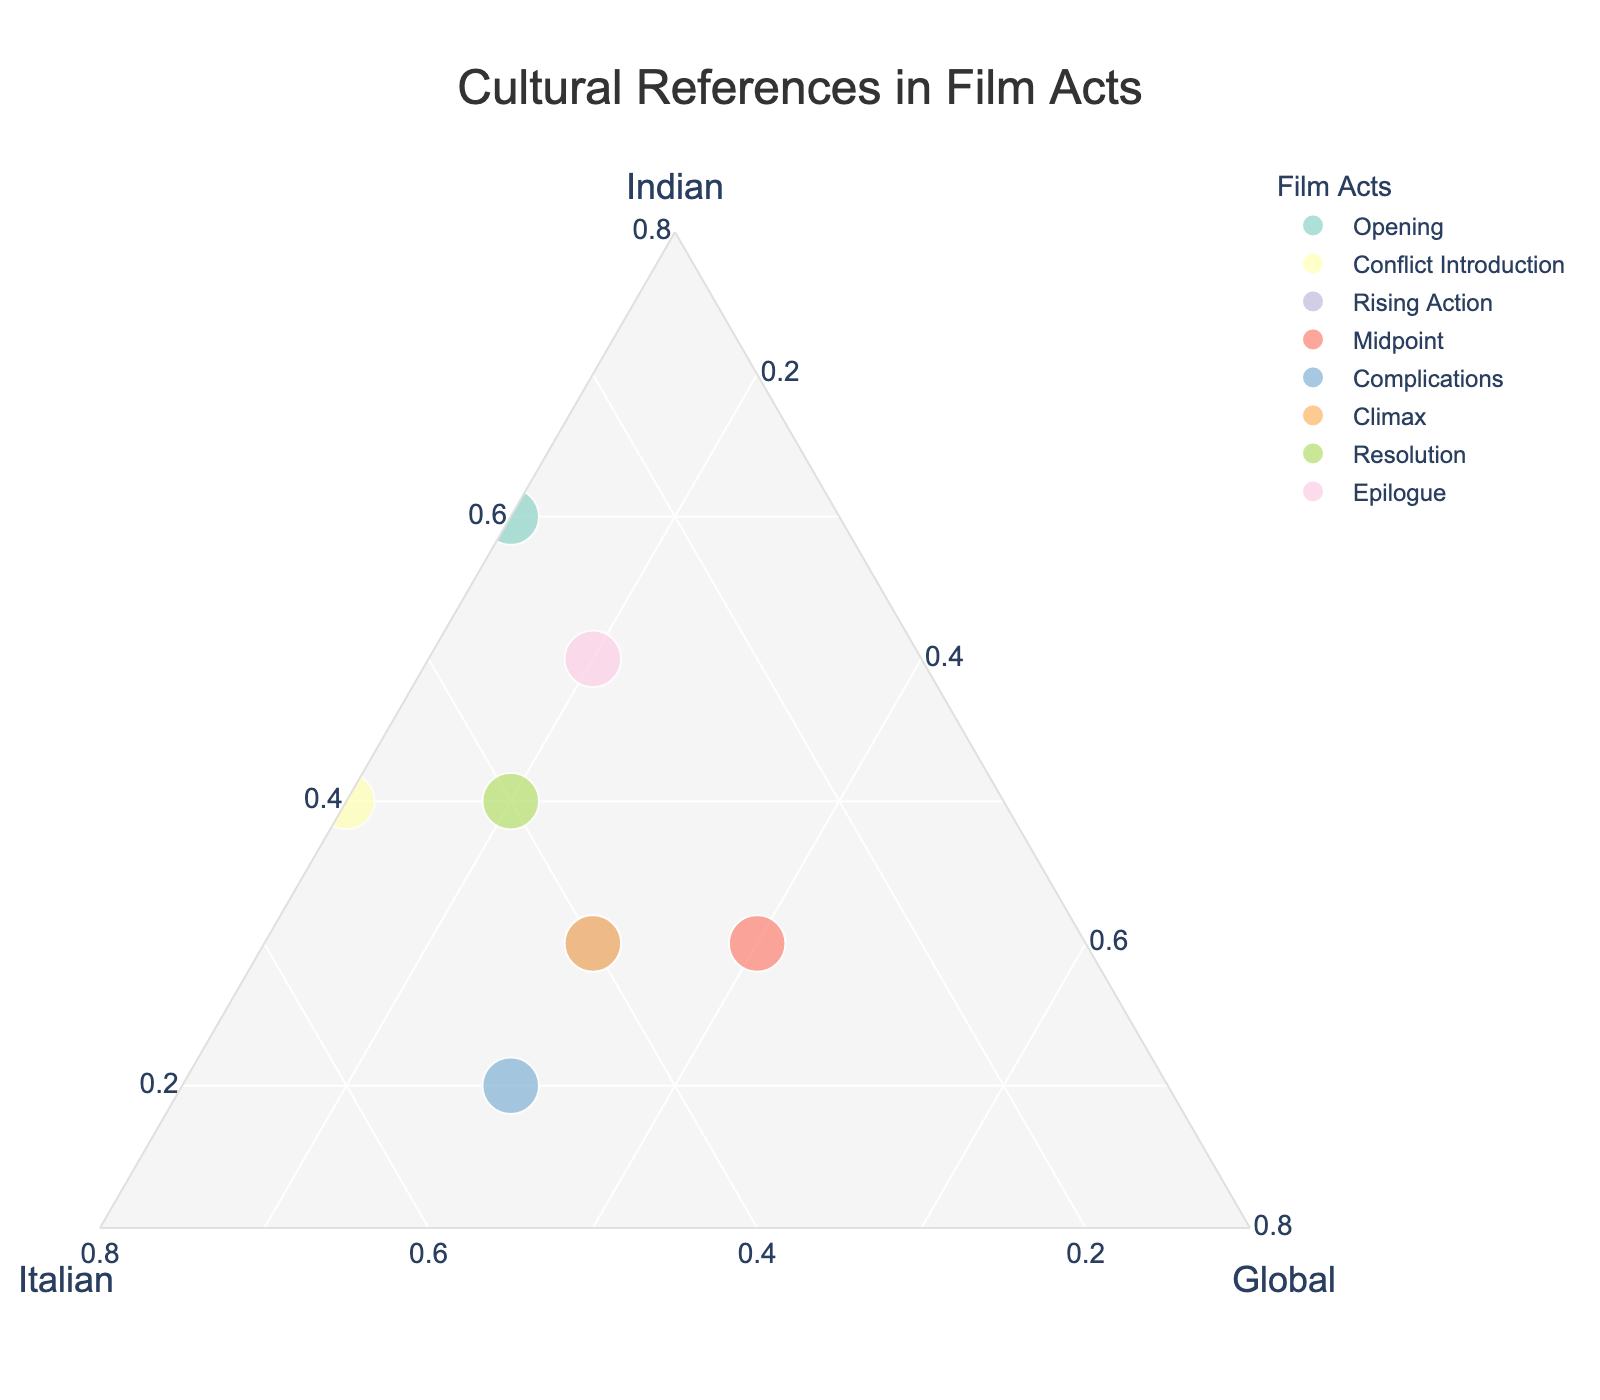What's the title of the plot? The title is clearly indicated at the top of the figure within the layout settings.
Answer: "Cultural References in Film Acts" Which act has the highest proportion of Indian cultural references? By examining the plot, we can see that the Opening act has the highest proportion of Indian cultural references with a value of 0.6.
Answer: Opening Which acts have an equal proportion of Indian and Italian cultural references? Upon inspecting the plot, the Midpoint and Resolution acts both show equal proportions of Indian and Italian cultural references, each with 0.3 and 0.4 respectively.
Answer: Midpoint, Resolution In which act is the proportion of global cultural references greater than the proportion of Indian cultural references? Observing the plot, the Midpoint act has a greater proportion of global cultural references (0.4) compared to Indian cultural references (0.3).
Answer: Midpoint What is the average proportion of Global cultural references across all acts? Adding the proportions of global references (0.1 + 0.1 + 0.3 + 0.4 + 0.3 + 0.3 + 0.2 + 0.2) which totals 1.9, and dividing by the number of acts (8), the average is 1.9/8 = 0.2375
Answer: 0.2375 How does the proportion of Indian cultural references in the Conflict Introduction act compare to the Complications act? The Conflict Introduction act has an Indian proportion of 0.4, whereas the Complications act has a lower Indian proportion of 0.2.
Answer: Conflict Introduction > Complications Which act has the largest combined proportion of Indian and Italian cultural references? Adding the proportions of Indian and Italian references for each act, we observe that the Complications act has the largest combined proportion (0.2 + 0.5 = 0.7).
Answer: Complications Does any act have a perfectly balanced proportion of Indian, Italian, and Global cultural references? Checking each act's values on the plot, none of the acts have equal proportions of Indian, Italian, and Global references. The closest is the Midpoint act with 0.3, 0.3, and 0.4 respectively, but it is not perfectly balanced.
Answer: No Which act exhibits a decrease in Indian cultural references relative to its preceding act? Comparing the proportions for each consecutive pair of acts, Indian references decrease in the Complications act (0.2) compared to the Midpoint act (0.3).
Answer: Complications During which act is the balance of Italian and Global cultural references exactly the same? The plot shows that the Midpoint act has equal proportions of Italian and Global references, both at 0.3.
Answer: Midpoint 